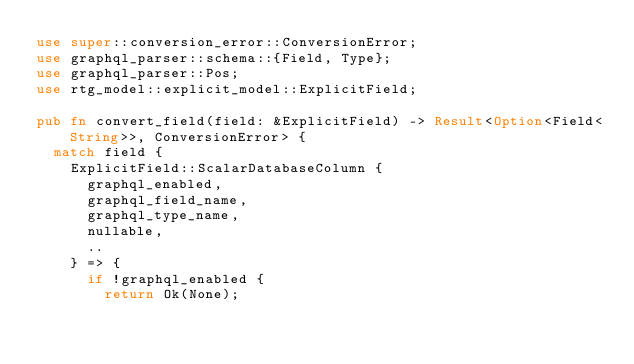Convert code to text. <code><loc_0><loc_0><loc_500><loc_500><_Rust_>use super::conversion_error::ConversionError;
use graphql_parser::schema::{Field, Type};
use graphql_parser::Pos;
use rtg_model::explicit_model::ExplicitField;

pub fn convert_field(field: &ExplicitField) -> Result<Option<Field<String>>, ConversionError> {
  match field {
    ExplicitField::ScalarDatabaseColumn {
      graphql_enabled,
      graphql_field_name,
      graphql_type_name,
      nullable,
      ..
    } => {
      if !graphql_enabled {
        return Ok(None);</code> 